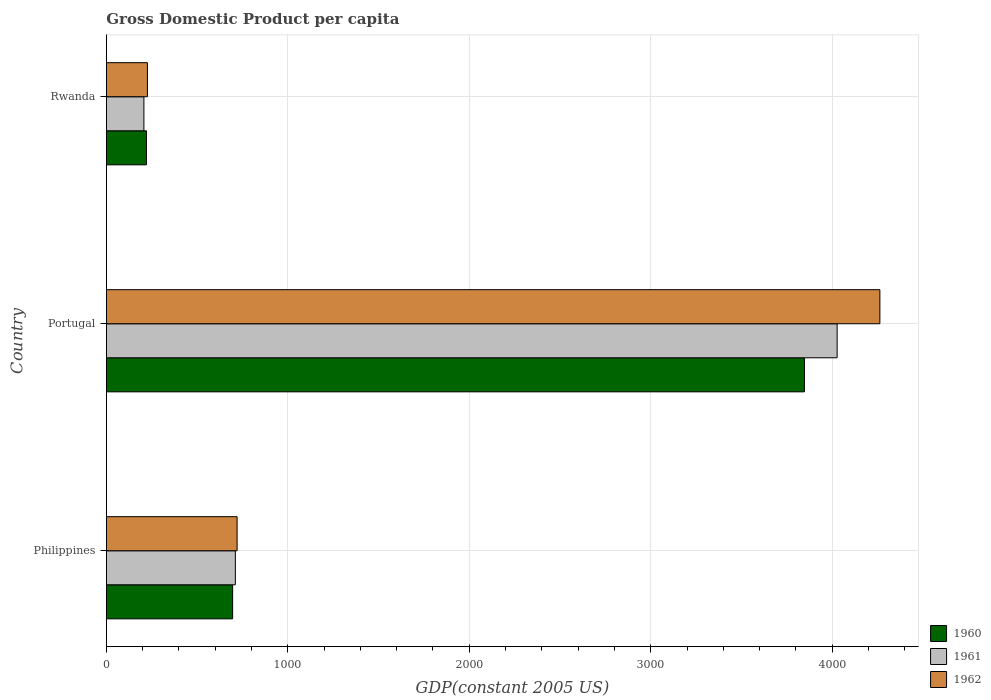How many groups of bars are there?
Your answer should be very brief. 3. How many bars are there on the 1st tick from the bottom?
Your answer should be very brief. 3. What is the GDP per capita in 1961 in Portugal?
Provide a succinct answer. 4027.06. Across all countries, what is the maximum GDP per capita in 1962?
Offer a very short reply. 4262.56. Across all countries, what is the minimum GDP per capita in 1962?
Your response must be concise. 226.42. In which country was the GDP per capita in 1961 minimum?
Offer a very short reply. Rwanda. What is the total GDP per capita in 1962 in the graph?
Your answer should be compact. 5209.58. What is the difference between the GDP per capita in 1962 in Portugal and that in Rwanda?
Ensure brevity in your answer.  4036.14. What is the difference between the GDP per capita in 1961 in Philippines and the GDP per capita in 1962 in Portugal?
Ensure brevity in your answer.  -3551.57. What is the average GDP per capita in 1962 per country?
Give a very brief answer. 1736.53. What is the difference between the GDP per capita in 1961 and GDP per capita in 1960 in Philippines?
Offer a terse response. 14.96. What is the ratio of the GDP per capita in 1961 in Philippines to that in Rwanda?
Provide a succinct answer. 3.43. Is the GDP per capita in 1962 in Philippines less than that in Rwanda?
Offer a terse response. No. Is the difference between the GDP per capita in 1961 in Philippines and Portugal greater than the difference between the GDP per capita in 1960 in Philippines and Portugal?
Give a very brief answer. No. What is the difference between the highest and the second highest GDP per capita in 1960?
Ensure brevity in your answer.  3150.68. What is the difference between the highest and the lowest GDP per capita in 1962?
Provide a short and direct response. 4036.14. In how many countries, is the GDP per capita in 1960 greater than the average GDP per capita in 1960 taken over all countries?
Ensure brevity in your answer.  1. Is the sum of the GDP per capita in 1960 in Philippines and Rwanda greater than the maximum GDP per capita in 1961 across all countries?
Provide a short and direct response. No. What does the 2nd bar from the bottom in Portugal represents?
Provide a short and direct response. 1961. Is it the case that in every country, the sum of the GDP per capita in 1962 and GDP per capita in 1960 is greater than the GDP per capita in 1961?
Keep it short and to the point. Yes. Are the values on the major ticks of X-axis written in scientific E-notation?
Your answer should be compact. No. Does the graph contain any zero values?
Offer a terse response. No. What is the title of the graph?
Keep it short and to the point. Gross Domestic Product per capita. Does "1975" appear as one of the legend labels in the graph?
Keep it short and to the point. No. What is the label or title of the X-axis?
Make the answer very short. GDP(constant 2005 US). What is the label or title of the Y-axis?
Provide a succinct answer. Country. What is the GDP(constant 2005 US) of 1960 in Philippines?
Your answer should be very brief. 696.02. What is the GDP(constant 2005 US) in 1961 in Philippines?
Provide a short and direct response. 710.98. What is the GDP(constant 2005 US) of 1962 in Philippines?
Your response must be concise. 720.61. What is the GDP(constant 2005 US) of 1960 in Portugal?
Provide a short and direct response. 3846.7. What is the GDP(constant 2005 US) in 1961 in Portugal?
Make the answer very short. 4027.06. What is the GDP(constant 2005 US) in 1962 in Portugal?
Keep it short and to the point. 4262.56. What is the GDP(constant 2005 US) of 1960 in Rwanda?
Offer a terse response. 220.99. What is the GDP(constant 2005 US) in 1961 in Rwanda?
Offer a terse response. 207.07. What is the GDP(constant 2005 US) in 1962 in Rwanda?
Offer a terse response. 226.42. Across all countries, what is the maximum GDP(constant 2005 US) in 1960?
Offer a very short reply. 3846.7. Across all countries, what is the maximum GDP(constant 2005 US) of 1961?
Keep it short and to the point. 4027.06. Across all countries, what is the maximum GDP(constant 2005 US) of 1962?
Your response must be concise. 4262.56. Across all countries, what is the minimum GDP(constant 2005 US) of 1960?
Make the answer very short. 220.99. Across all countries, what is the minimum GDP(constant 2005 US) of 1961?
Give a very brief answer. 207.07. Across all countries, what is the minimum GDP(constant 2005 US) of 1962?
Ensure brevity in your answer.  226.42. What is the total GDP(constant 2005 US) of 1960 in the graph?
Your response must be concise. 4763.71. What is the total GDP(constant 2005 US) of 1961 in the graph?
Ensure brevity in your answer.  4945.11. What is the total GDP(constant 2005 US) of 1962 in the graph?
Provide a short and direct response. 5209.58. What is the difference between the GDP(constant 2005 US) in 1960 in Philippines and that in Portugal?
Your answer should be very brief. -3150.68. What is the difference between the GDP(constant 2005 US) of 1961 in Philippines and that in Portugal?
Your response must be concise. -3316.08. What is the difference between the GDP(constant 2005 US) of 1962 in Philippines and that in Portugal?
Provide a short and direct response. -3541.95. What is the difference between the GDP(constant 2005 US) of 1960 in Philippines and that in Rwanda?
Ensure brevity in your answer.  475.03. What is the difference between the GDP(constant 2005 US) of 1961 in Philippines and that in Rwanda?
Your answer should be very brief. 503.92. What is the difference between the GDP(constant 2005 US) in 1962 in Philippines and that in Rwanda?
Make the answer very short. 494.19. What is the difference between the GDP(constant 2005 US) in 1960 in Portugal and that in Rwanda?
Offer a terse response. 3625.72. What is the difference between the GDP(constant 2005 US) in 1961 in Portugal and that in Rwanda?
Keep it short and to the point. 3820. What is the difference between the GDP(constant 2005 US) in 1962 in Portugal and that in Rwanda?
Make the answer very short. 4036.14. What is the difference between the GDP(constant 2005 US) of 1960 in Philippines and the GDP(constant 2005 US) of 1961 in Portugal?
Make the answer very short. -3331.04. What is the difference between the GDP(constant 2005 US) in 1960 in Philippines and the GDP(constant 2005 US) in 1962 in Portugal?
Offer a terse response. -3566.54. What is the difference between the GDP(constant 2005 US) in 1961 in Philippines and the GDP(constant 2005 US) in 1962 in Portugal?
Offer a terse response. -3551.57. What is the difference between the GDP(constant 2005 US) in 1960 in Philippines and the GDP(constant 2005 US) in 1961 in Rwanda?
Provide a succinct answer. 488.95. What is the difference between the GDP(constant 2005 US) in 1960 in Philippines and the GDP(constant 2005 US) in 1962 in Rwanda?
Give a very brief answer. 469.6. What is the difference between the GDP(constant 2005 US) in 1961 in Philippines and the GDP(constant 2005 US) in 1962 in Rwanda?
Offer a terse response. 484.57. What is the difference between the GDP(constant 2005 US) of 1960 in Portugal and the GDP(constant 2005 US) of 1961 in Rwanda?
Your answer should be very brief. 3639.64. What is the difference between the GDP(constant 2005 US) of 1960 in Portugal and the GDP(constant 2005 US) of 1962 in Rwanda?
Your answer should be compact. 3620.29. What is the difference between the GDP(constant 2005 US) of 1961 in Portugal and the GDP(constant 2005 US) of 1962 in Rwanda?
Provide a succinct answer. 3800.65. What is the average GDP(constant 2005 US) of 1960 per country?
Keep it short and to the point. 1587.9. What is the average GDP(constant 2005 US) in 1961 per country?
Provide a succinct answer. 1648.37. What is the average GDP(constant 2005 US) in 1962 per country?
Keep it short and to the point. 1736.53. What is the difference between the GDP(constant 2005 US) in 1960 and GDP(constant 2005 US) in 1961 in Philippines?
Your answer should be very brief. -14.96. What is the difference between the GDP(constant 2005 US) in 1960 and GDP(constant 2005 US) in 1962 in Philippines?
Your response must be concise. -24.59. What is the difference between the GDP(constant 2005 US) of 1961 and GDP(constant 2005 US) of 1962 in Philippines?
Provide a succinct answer. -9.62. What is the difference between the GDP(constant 2005 US) of 1960 and GDP(constant 2005 US) of 1961 in Portugal?
Your response must be concise. -180.36. What is the difference between the GDP(constant 2005 US) of 1960 and GDP(constant 2005 US) of 1962 in Portugal?
Keep it short and to the point. -415.86. What is the difference between the GDP(constant 2005 US) of 1961 and GDP(constant 2005 US) of 1962 in Portugal?
Make the answer very short. -235.5. What is the difference between the GDP(constant 2005 US) in 1960 and GDP(constant 2005 US) in 1961 in Rwanda?
Make the answer very short. 13.92. What is the difference between the GDP(constant 2005 US) in 1960 and GDP(constant 2005 US) in 1962 in Rwanda?
Provide a succinct answer. -5.43. What is the difference between the GDP(constant 2005 US) in 1961 and GDP(constant 2005 US) in 1962 in Rwanda?
Provide a succinct answer. -19.35. What is the ratio of the GDP(constant 2005 US) in 1960 in Philippines to that in Portugal?
Make the answer very short. 0.18. What is the ratio of the GDP(constant 2005 US) of 1961 in Philippines to that in Portugal?
Your answer should be very brief. 0.18. What is the ratio of the GDP(constant 2005 US) in 1962 in Philippines to that in Portugal?
Your response must be concise. 0.17. What is the ratio of the GDP(constant 2005 US) of 1960 in Philippines to that in Rwanda?
Your response must be concise. 3.15. What is the ratio of the GDP(constant 2005 US) in 1961 in Philippines to that in Rwanda?
Ensure brevity in your answer.  3.43. What is the ratio of the GDP(constant 2005 US) in 1962 in Philippines to that in Rwanda?
Offer a very short reply. 3.18. What is the ratio of the GDP(constant 2005 US) of 1960 in Portugal to that in Rwanda?
Your answer should be very brief. 17.41. What is the ratio of the GDP(constant 2005 US) in 1961 in Portugal to that in Rwanda?
Your answer should be compact. 19.45. What is the ratio of the GDP(constant 2005 US) in 1962 in Portugal to that in Rwanda?
Offer a terse response. 18.83. What is the difference between the highest and the second highest GDP(constant 2005 US) in 1960?
Provide a short and direct response. 3150.68. What is the difference between the highest and the second highest GDP(constant 2005 US) in 1961?
Offer a very short reply. 3316.08. What is the difference between the highest and the second highest GDP(constant 2005 US) in 1962?
Provide a short and direct response. 3541.95. What is the difference between the highest and the lowest GDP(constant 2005 US) of 1960?
Make the answer very short. 3625.72. What is the difference between the highest and the lowest GDP(constant 2005 US) in 1961?
Your response must be concise. 3820. What is the difference between the highest and the lowest GDP(constant 2005 US) of 1962?
Make the answer very short. 4036.14. 